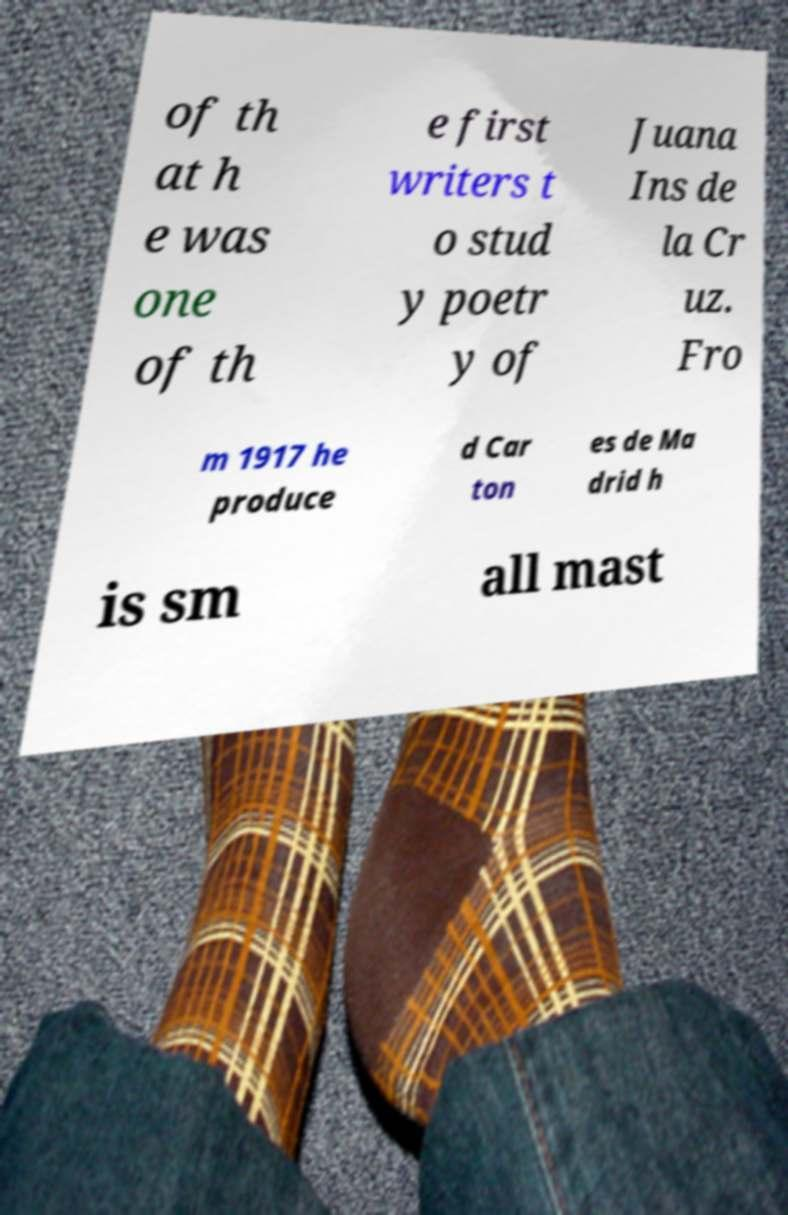Could you assist in decoding the text presented in this image and type it out clearly? of th at h e was one of th e first writers t o stud y poetr y of Juana Ins de la Cr uz. Fro m 1917 he produce d Car ton es de Ma drid h is sm all mast 